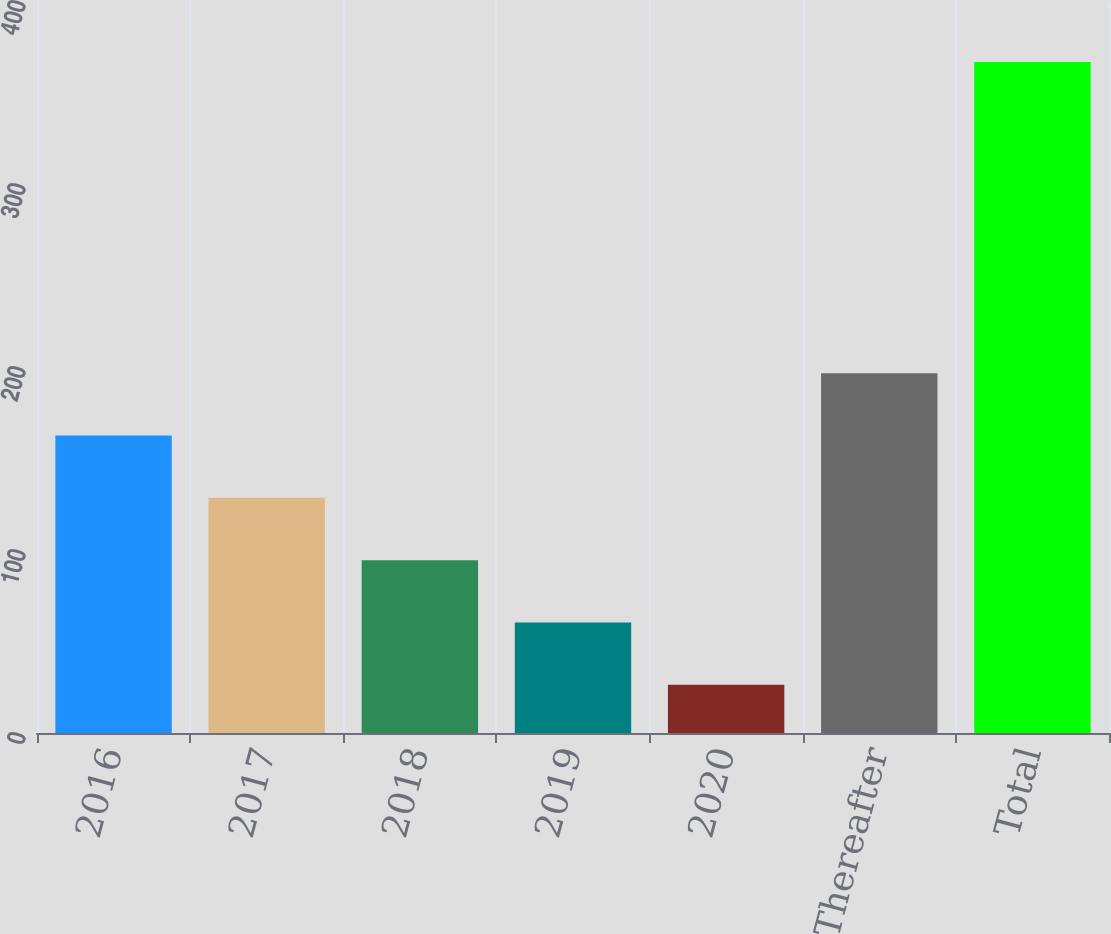Convert chart. <chart><loc_0><loc_0><loc_500><loc_500><bar_chart><fcel>2016<fcel>2017<fcel>2018<fcel>2019<fcel>2020<fcel>Thereafter<fcel>Total<nl><fcel>162.52<fcel>128.49<fcel>94.46<fcel>60.43<fcel>26.4<fcel>196.55<fcel>366.7<nl></chart> 